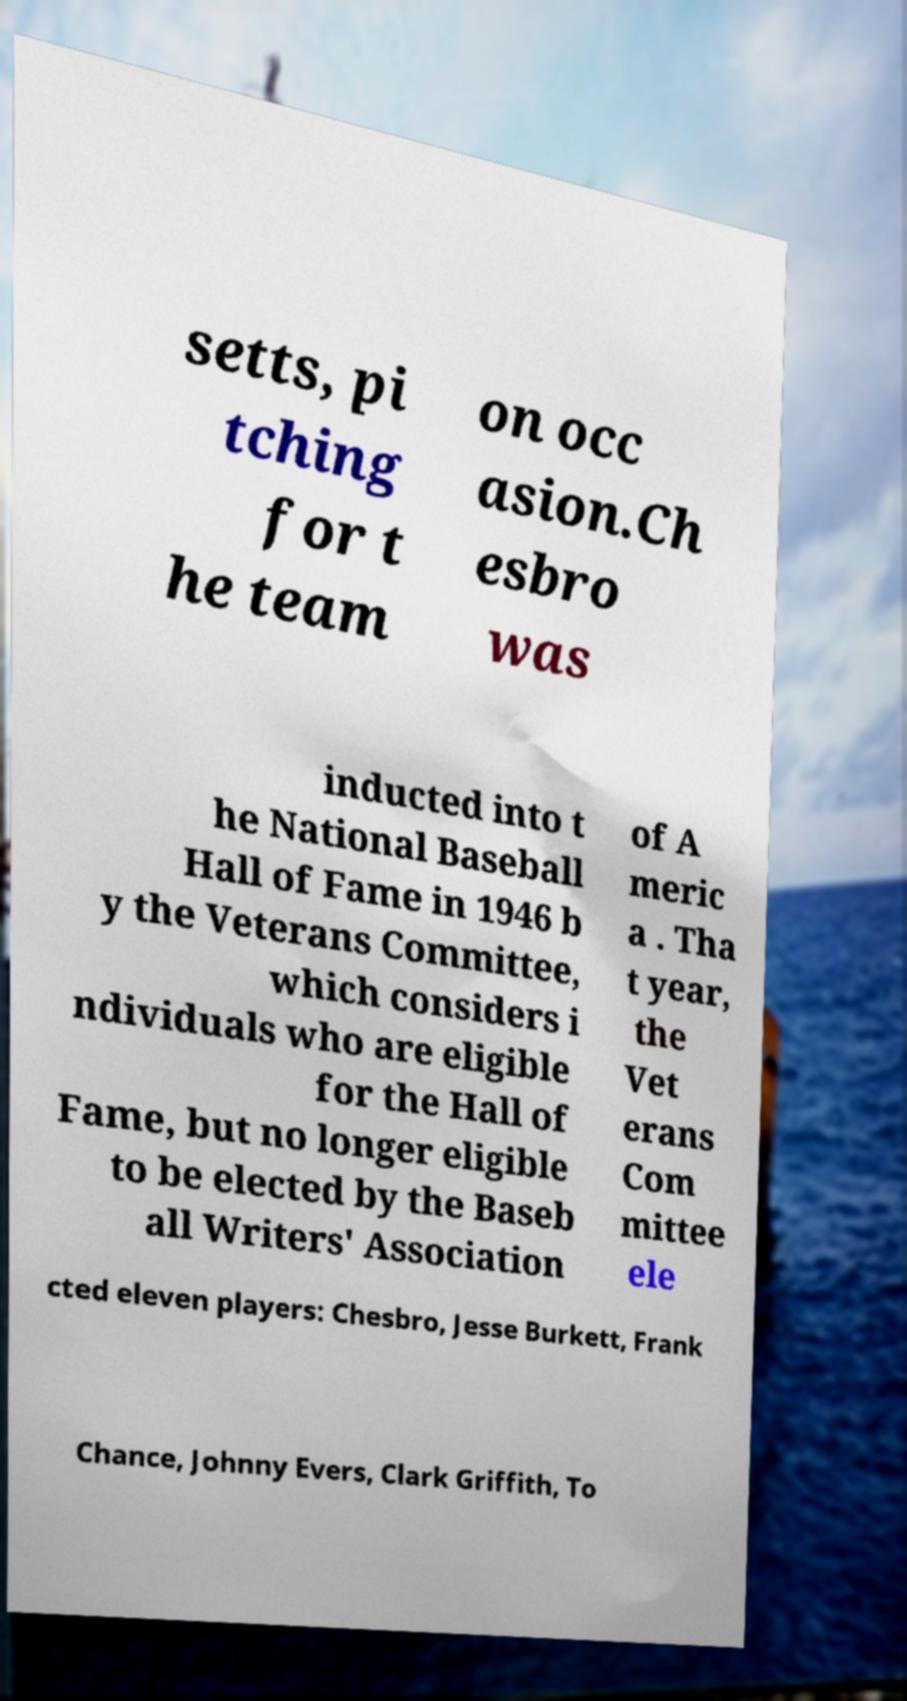Could you extract and type out the text from this image? setts, pi tching for t he team on occ asion.Ch esbro was inducted into t he National Baseball Hall of Fame in 1946 b y the Veterans Committee, which considers i ndividuals who are eligible for the Hall of Fame, but no longer eligible to be elected by the Baseb all Writers' Association of A meric a . Tha t year, the Vet erans Com mittee ele cted eleven players: Chesbro, Jesse Burkett, Frank Chance, Johnny Evers, Clark Griffith, To 